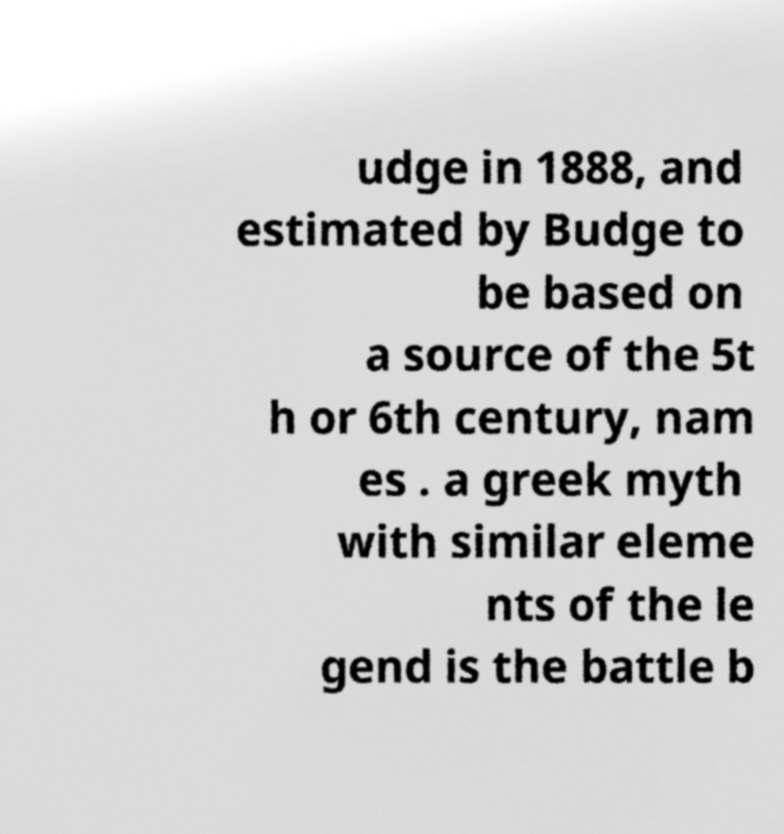Could you assist in decoding the text presented in this image and type it out clearly? udge in 1888, and estimated by Budge to be based on a source of the 5t h or 6th century, nam es . a greek myth with similar eleme nts of the le gend is the battle b 